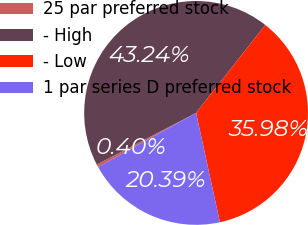<chart> <loc_0><loc_0><loc_500><loc_500><pie_chart><fcel>25 par preferred stock<fcel>- High<fcel>- Low<fcel>1 par series D preferred stock<nl><fcel>0.4%<fcel>43.24%<fcel>35.98%<fcel>20.39%<nl></chart> 